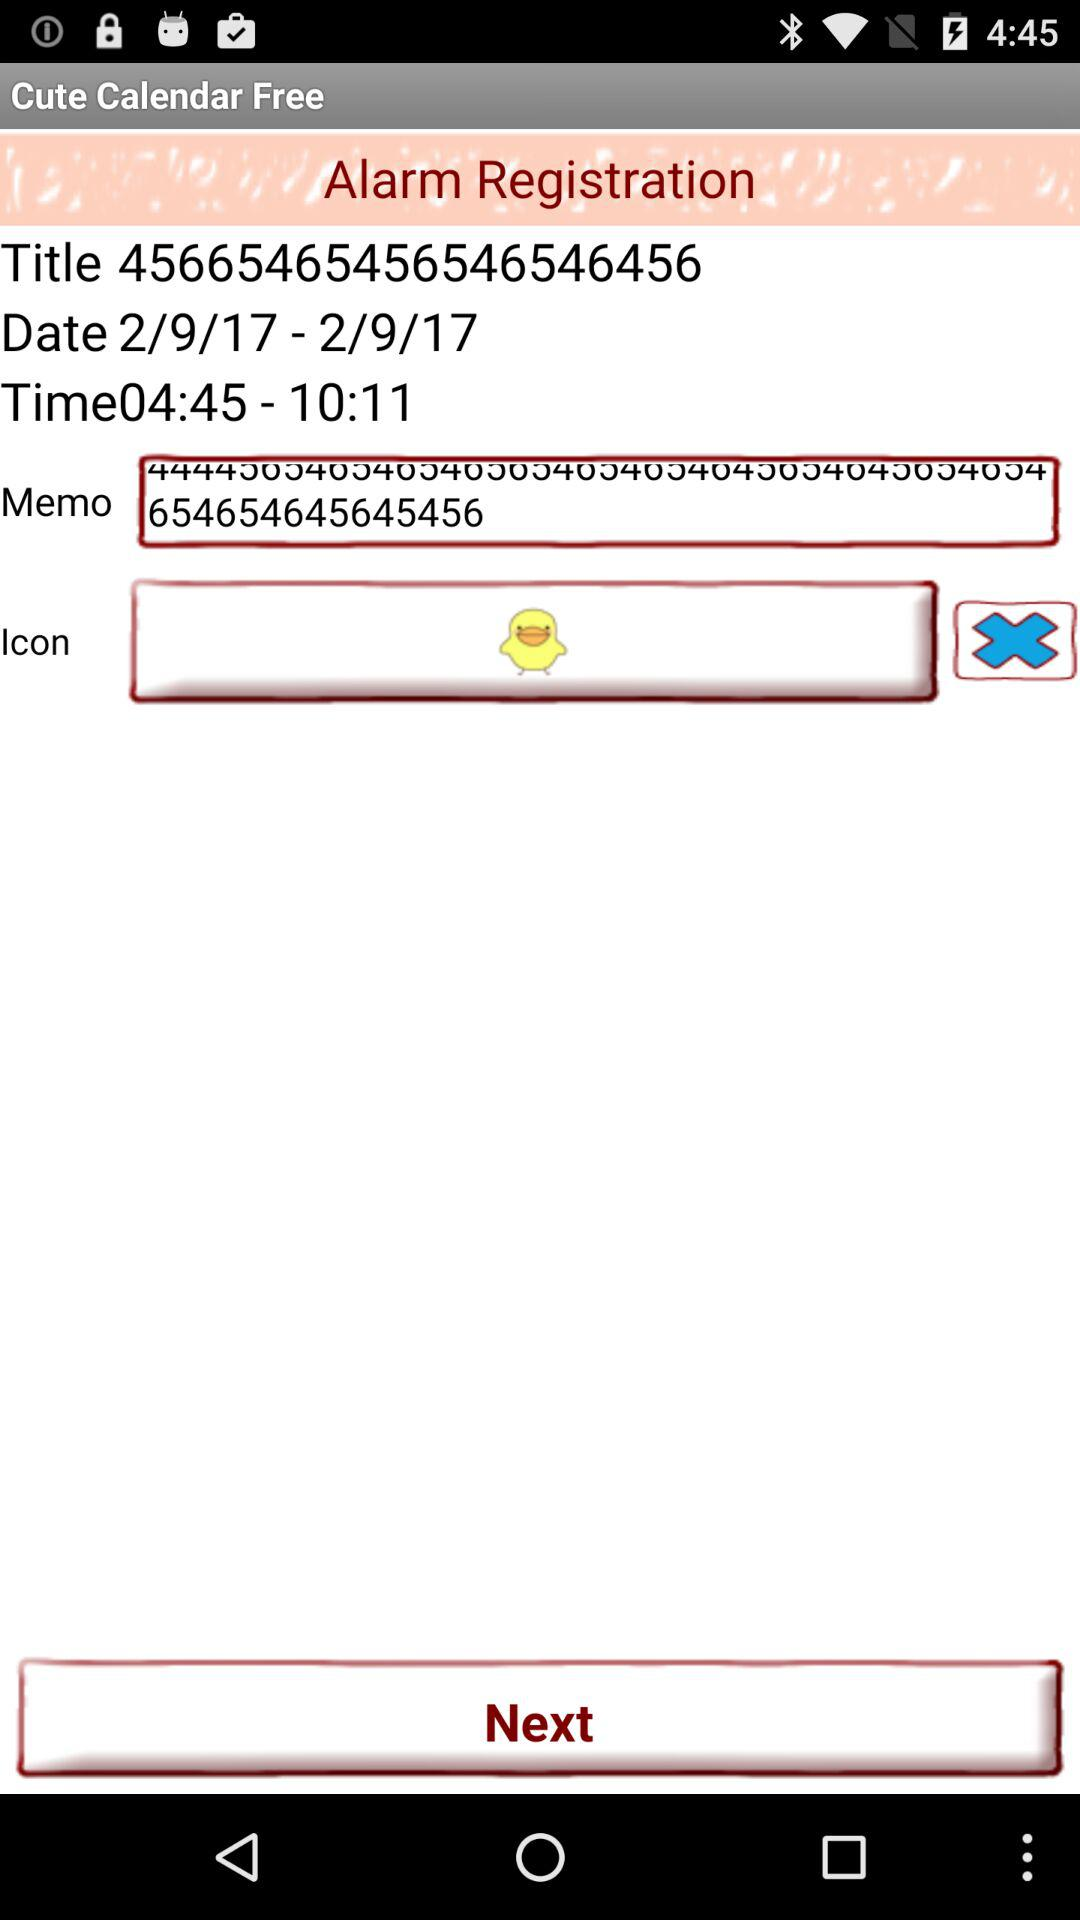What is the selected date range? The selected date range is from February 9, 2017 to February 9, 2017. 